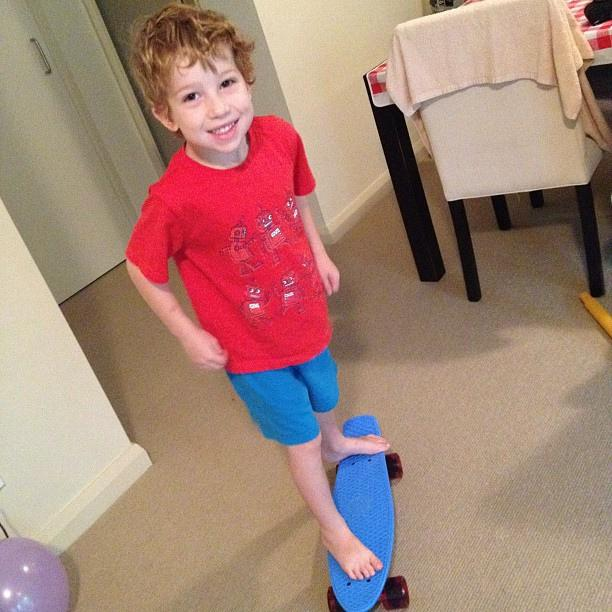The color of the boy's outfit matches the colors of the costume of what super hero? superman 